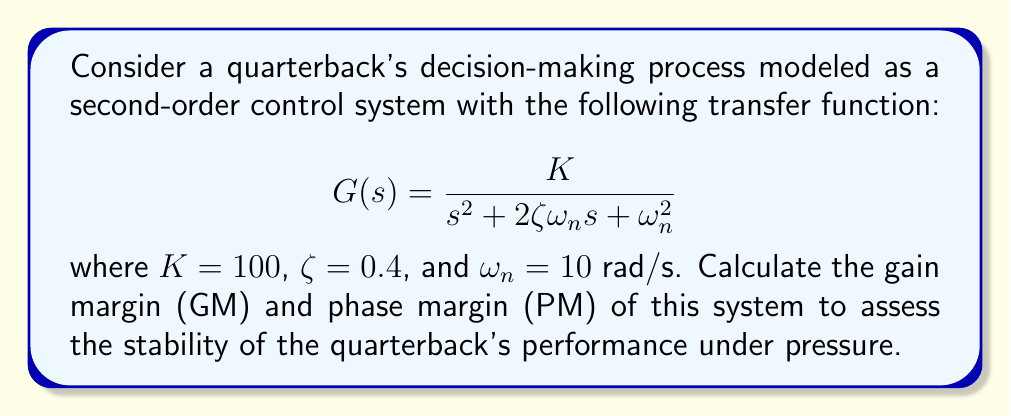Teach me how to tackle this problem. To determine the stability margins, we need to analyze the open-loop transfer function $G(s)$. Let's follow these steps:

1) First, we substitute the given values into the transfer function:

   $$G(s) = \frac{100}{s^2 + 8s + 100}$$

2) To find the gain margin, we need to determine the frequency where the phase angle is -180°. At this frequency, the gain should be less than 1 (0 dB) for stability.

3) To find the phase margin, we need to determine the frequency where the magnitude is 1 (0 dB) and calculate how much additional phase lag would be required to reach -180°.

4) Let's start by finding the system's frequency response:

   $$G(j\omega) = \frac{100}{(j\omega)^2 + 8(j\omega) + 100} = \frac{100}{100 - \omega^2 + 8j\omega}$$

5) The magnitude of $G(j\omega)$ is:

   $$|G(j\omega)| = \frac{100}{\sqrt{(100 - \omega^2)^2 + (8\omega)^2}}$$

6) The phase angle of $G(j\omega)$ is:

   $$\angle G(j\omega) = -\tan^{-1}\left(\frac{8\omega}{100 - \omega^2}\right)$$

7) For the gain margin, we need to find $\omega$ where $\angle G(j\omega) = -180°$. This occurs when:

   $$\frac{8\omega}{100 - \omega^2} \to \infty$$

   This happens when $100 - \omega^2 = 0$, or $\omega = 10$ rad/s.

8) At $\omega = 10$ rad/s, the magnitude is:

   $$|G(j10)| = \frac{100}{\sqrt{0^2 + 80^2}} = \frac{100}{80} = 1.25$$

9) The gain margin in dB is:

   $$GM = -20 \log_{10}(1.25) = -1.94 \text{ dB}$$

10) For the phase margin, we need to find $\omega$ where $|G(j\omega)| = 1$. This occurs when:

    $$\frac{100}{\sqrt{(100 - \omega^2)^2 + (8\omega)^2}} = 1$$

    Solving this equation numerically gives us $\omega \approx 8.16$ rad/s.

11) At this frequency, the phase angle is:

    $$\angle G(j8.16) = -\tan^{-1}\left(\frac{8 \cdot 8.16}{100 - 8.16^2}\right) \approx -134.7°$$

12) The phase margin is the difference between this angle and -180°:

    $$PM = -180° - (-134.7°) = -45.3°$$
Answer: Gain Margin (GM) = -1.94 dB
Phase Margin (PM) = 45.3° 